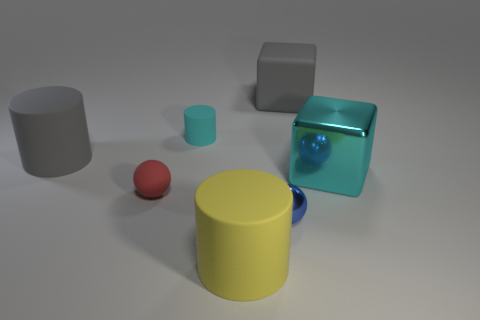Are there any other things that are the same color as the large shiny object?
Make the answer very short. Yes. The large object that is on the right side of the red sphere and behind the big metal block has what shape?
Keep it short and to the point. Cube. There is a cyan object that is on the left side of the blue metallic ball; what is its size?
Provide a short and direct response. Small. How many large metallic blocks are in front of the gray matte thing in front of the gray thing on the right side of the small blue sphere?
Provide a succinct answer. 1. There is a cyan metallic cube; are there any small metal balls behind it?
Your response must be concise. No. What number of other objects are there of the same size as the rubber cube?
Provide a succinct answer. 3. What is the big thing that is behind the blue object and left of the small blue shiny ball made of?
Your answer should be compact. Rubber. There is a shiny object that is behind the blue shiny object; is it the same shape as the big gray object that is to the right of the blue metal sphere?
Your response must be concise. Yes. What is the shape of the large object that is to the left of the small matte ball that is left of the large gray thing that is on the right side of the big gray matte cylinder?
Give a very brief answer. Cylinder. How many other objects are there of the same shape as the large metal object?
Your answer should be very brief. 1. 